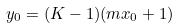Convert formula to latex. <formula><loc_0><loc_0><loc_500><loc_500>y _ { 0 } = ( K - 1 ) ( m x _ { 0 } + 1 )</formula> 